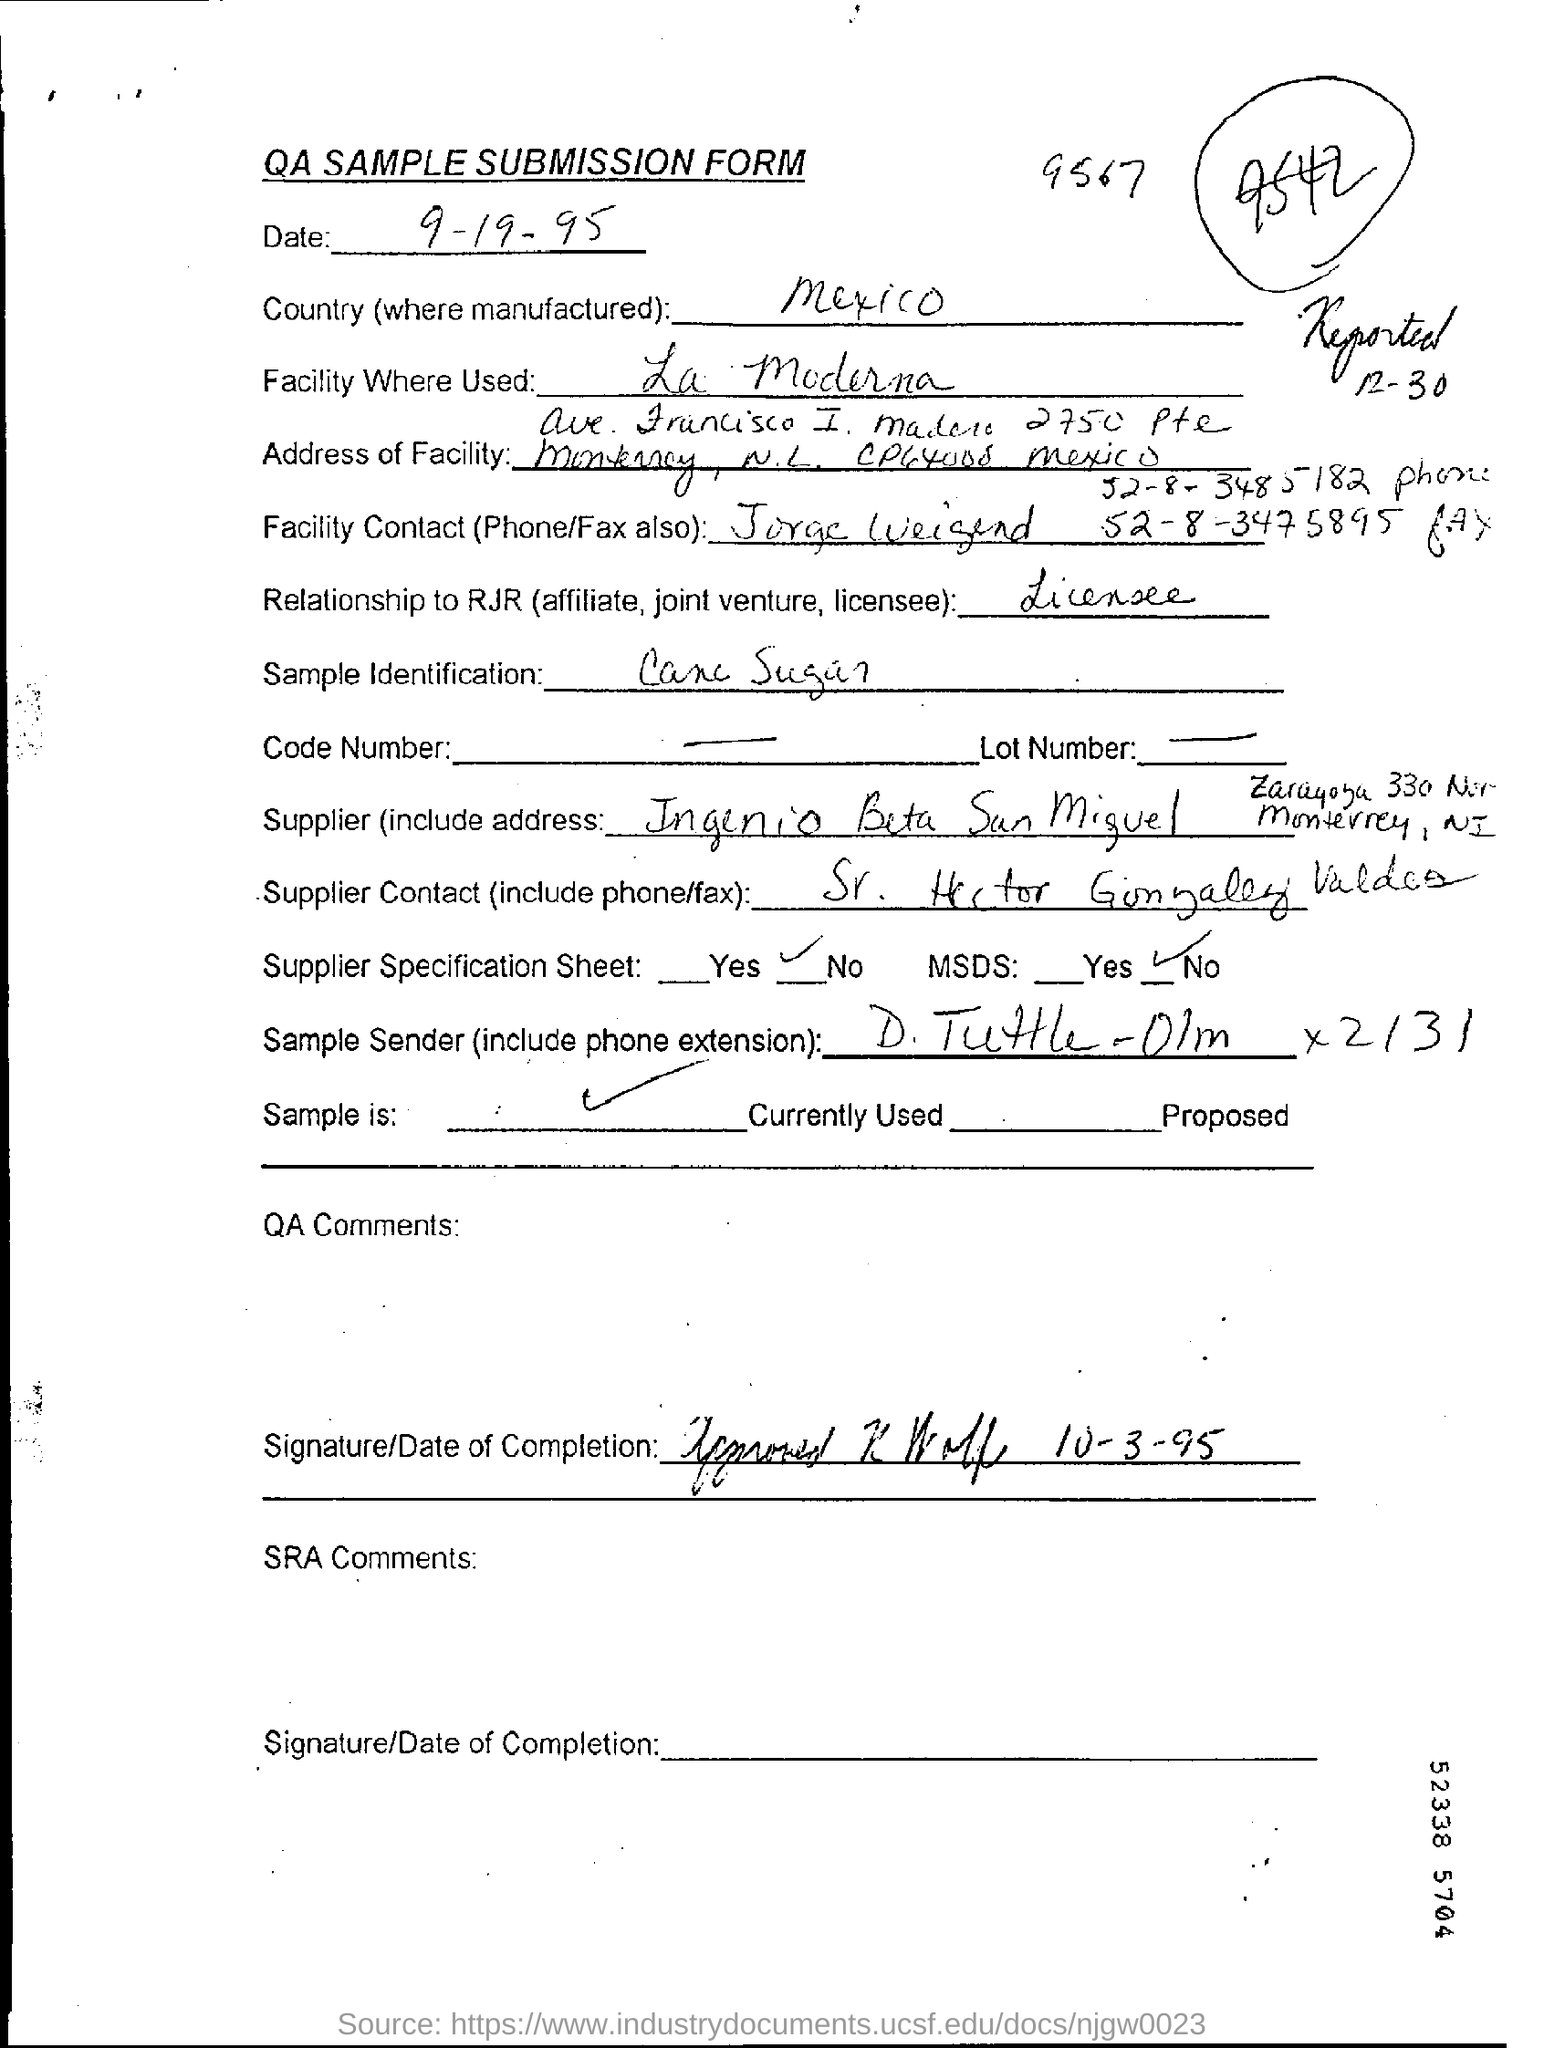List a handful of essential elements in this visual. The country in which the product is manufactured is Mexico. The form that is being referred to is the QA, SAMPLE SUBMISSION FORM. The sample used for identification is cane sugar. 